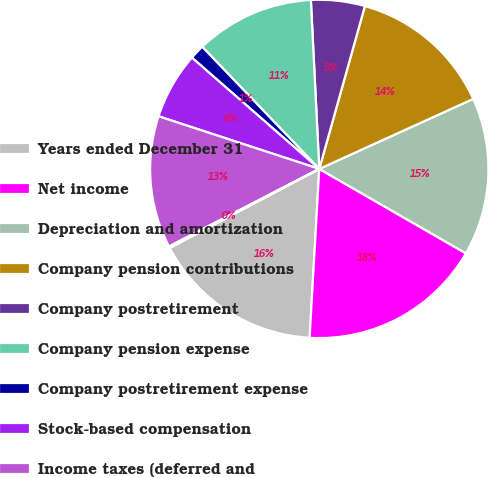Convert chart to OTSL. <chart><loc_0><loc_0><loc_500><loc_500><pie_chart><fcel>Years ended December 31<fcel>Net income<fcel>Depreciation and amortization<fcel>Company pension contributions<fcel>Company postretirement<fcel>Company pension expense<fcel>Company postretirement expense<fcel>Stock-based compensation<fcel>Income taxes (deferred and<fcel>Excess tax benefits from<nl><fcel>16.35%<fcel>17.6%<fcel>15.11%<fcel>13.86%<fcel>5.14%<fcel>11.37%<fcel>1.41%<fcel>6.39%<fcel>12.62%<fcel>0.16%<nl></chart> 